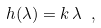<formula> <loc_0><loc_0><loc_500><loc_500>h ( \lambda ) = k \, \lambda \ ,</formula> 